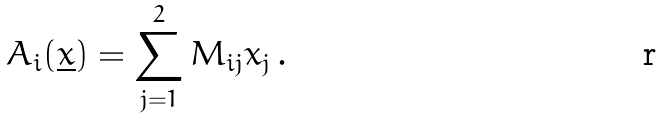Convert formula to latex. <formula><loc_0><loc_0><loc_500><loc_500>A _ { i } ( \underline { x } ) = \sum ^ { 2 } _ { j = 1 } M _ { i j } x _ { j } \, .</formula> 